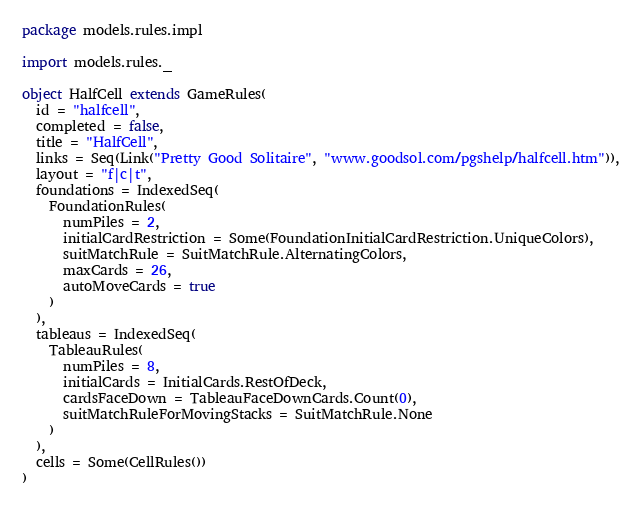<code> <loc_0><loc_0><loc_500><loc_500><_Scala_>package models.rules.impl

import models.rules._

object HalfCell extends GameRules(
  id = "halfcell",
  completed = false,
  title = "HalfCell",
  links = Seq(Link("Pretty Good Solitaire", "www.goodsol.com/pgshelp/halfcell.htm")),
  layout = "f|c|t",
  foundations = IndexedSeq(
    FoundationRules(
      numPiles = 2,
      initialCardRestriction = Some(FoundationInitialCardRestriction.UniqueColors),
      suitMatchRule = SuitMatchRule.AlternatingColors,
      maxCards = 26,
      autoMoveCards = true
    )
  ),
  tableaus = IndexedSeq(
    TableauRules(
      numPiles = 8,
      initialCards = InitialCards.RestOfDeck,
      cardsFaceDown = TableauFaceDownCards.Count(0),
      suitMatchRuleForMovingStacks = SuitMatchRule.None
    )
  ),
  cells = Some(CellRules())
)
</code> 